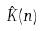<formula> <loc_0><loc_0><loc_500><loc_500>\hat { K } ( n )</formula> 